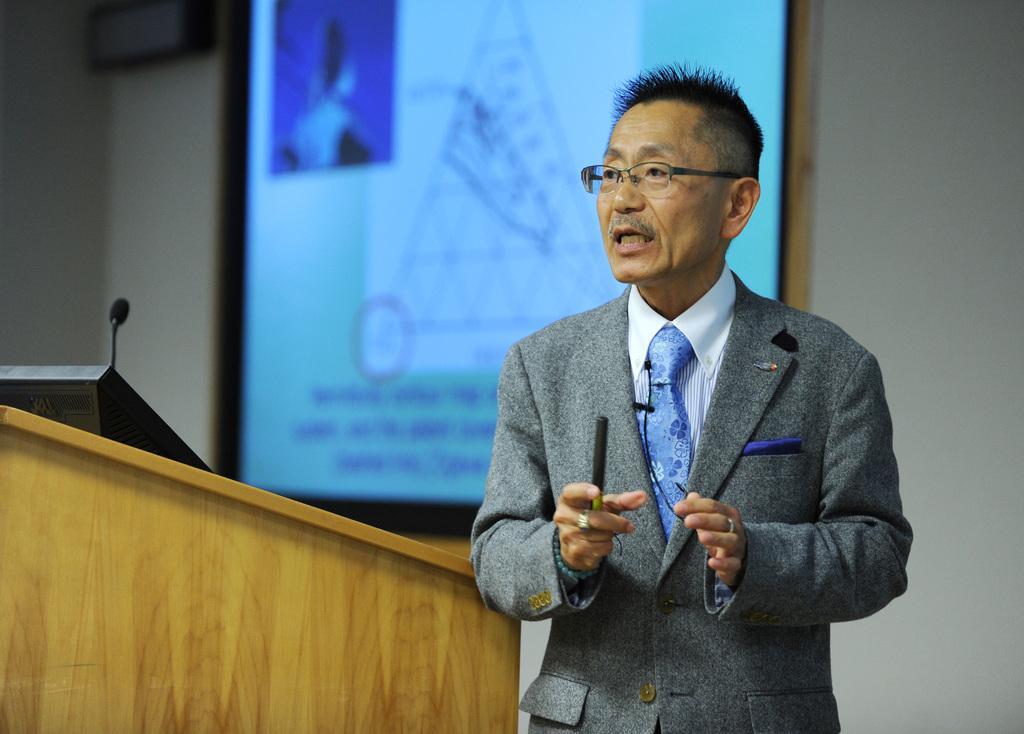Please provide a concise description of this image. In the picture we can see a person wearing grey color suit standing near the podium on which there is screen and there is microphone and in the background of the picture there is projector screen which is attached to the wall. 